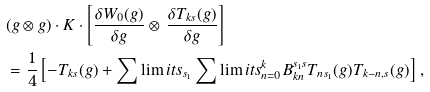Convert formula to latex. <formula><loc_0><loc_0><loc_500><loc_500>& ( g \otimes g ) \cdot K \cdot \left [ \frac { \delta W _ { 0 } ( g ) } { \delta g } \otimes \, \frac { \delta T _ { k s } ( g ) } { \delta g } \right ] \\ & = \frac { 1 } { 4 } \left [ - T _ { k s } ( g ) + \sum \lim i t s _ { s _ { 1 } } \sum \lim i t s _ { n = 0 } ^ { k } B _ { k n } ^ { s _ { 1 } s } T _ { n s _ { 1 } } ( g ) T _ { k - n , s } ( g ) \right ] \, ,</formula> 